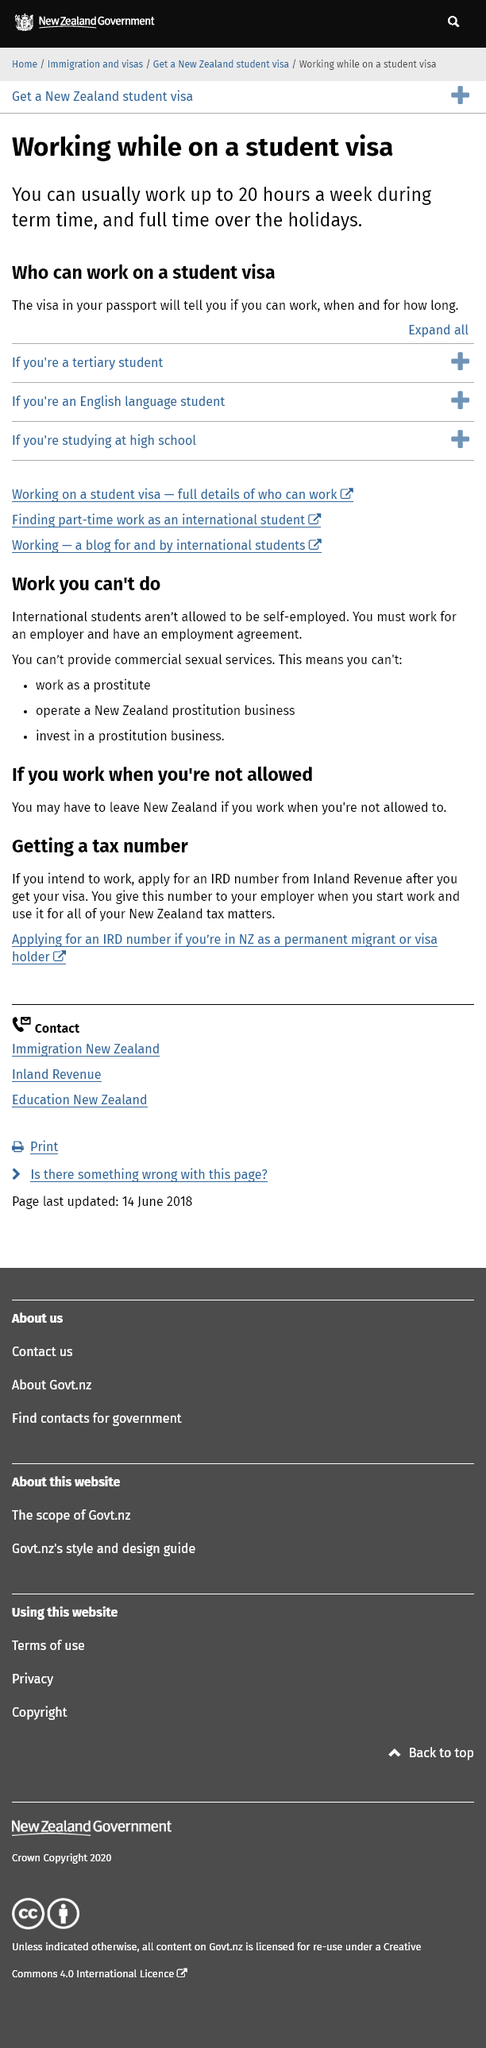Draw attention to some important aspects in this diagram. It is possible to determine if you are eligible to work while on a student visa by examining the restrictions listed on your visa in your passport. The text can be converted to: "How long can I work on a student visa? Please check your passport for any restrictions. Yes, I am able to work on a student visa, with the ability to work up to 20 hours per week during term time and full-time during the holidays. 